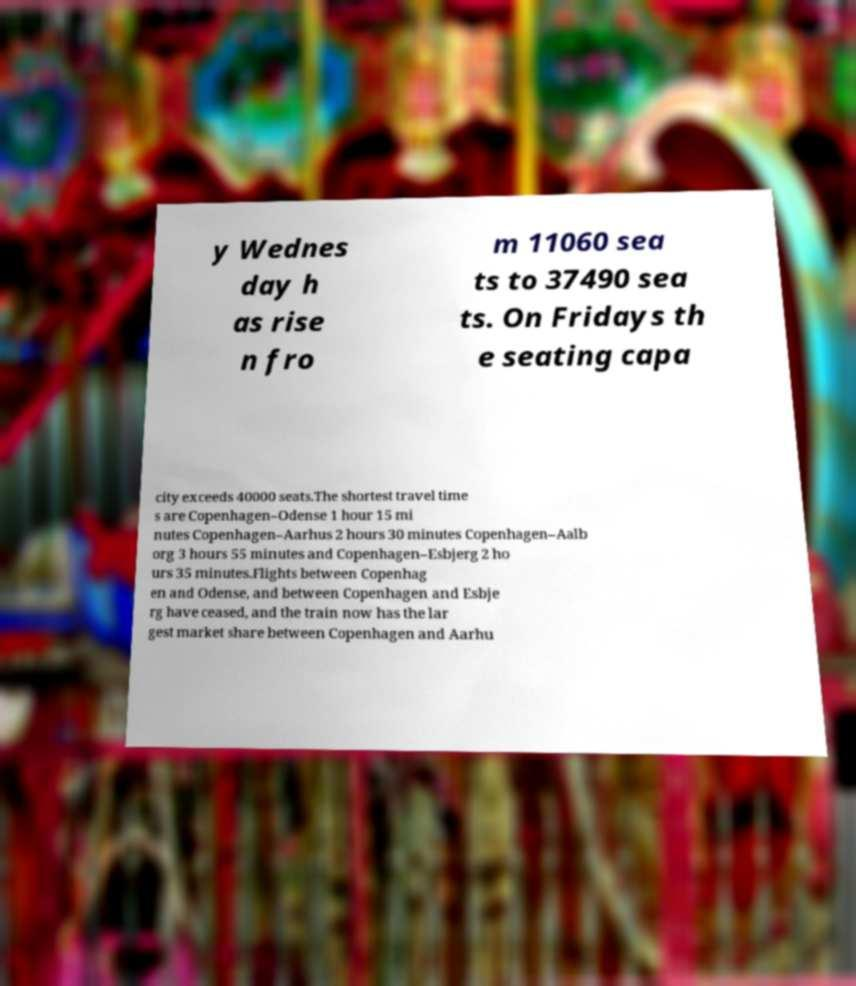For documentation purposes, I need the text within this image transcribed. Could you provide that? y Wednes day h as rise n fro m 11060 sea ts to 37490 sea ts. On Fridays th e seating capa city exceeds 40000 seats.The shortest travel time s are Copenhagen–Odense 1 hour 15 mi nutes Copenhagen–Aarhus 2 hours 30 minutes Copenhagen–Aalb org 3 hours 55 minutes and Copenhagen–Esbjerg 2 ho urs 35 minutes.Flights between Copenhag en and Odense, and between Copenhagen and Esbje rg have ceased, and the train now has the lar gest market share between Copenhagen and Aarhu 